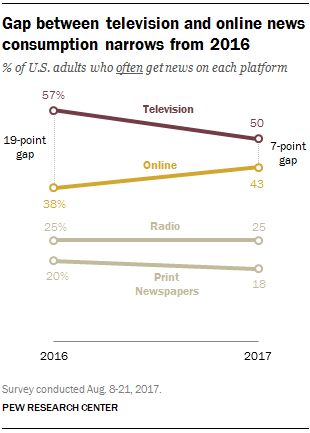Give some essential details in this illustration. The rightmost value of the "Online" graph is 43. The average value of the Television graph is 53.5. 